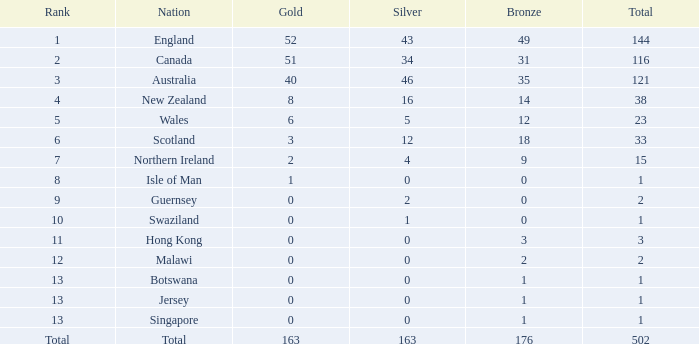Name the average bronze for total less than 1 None. 